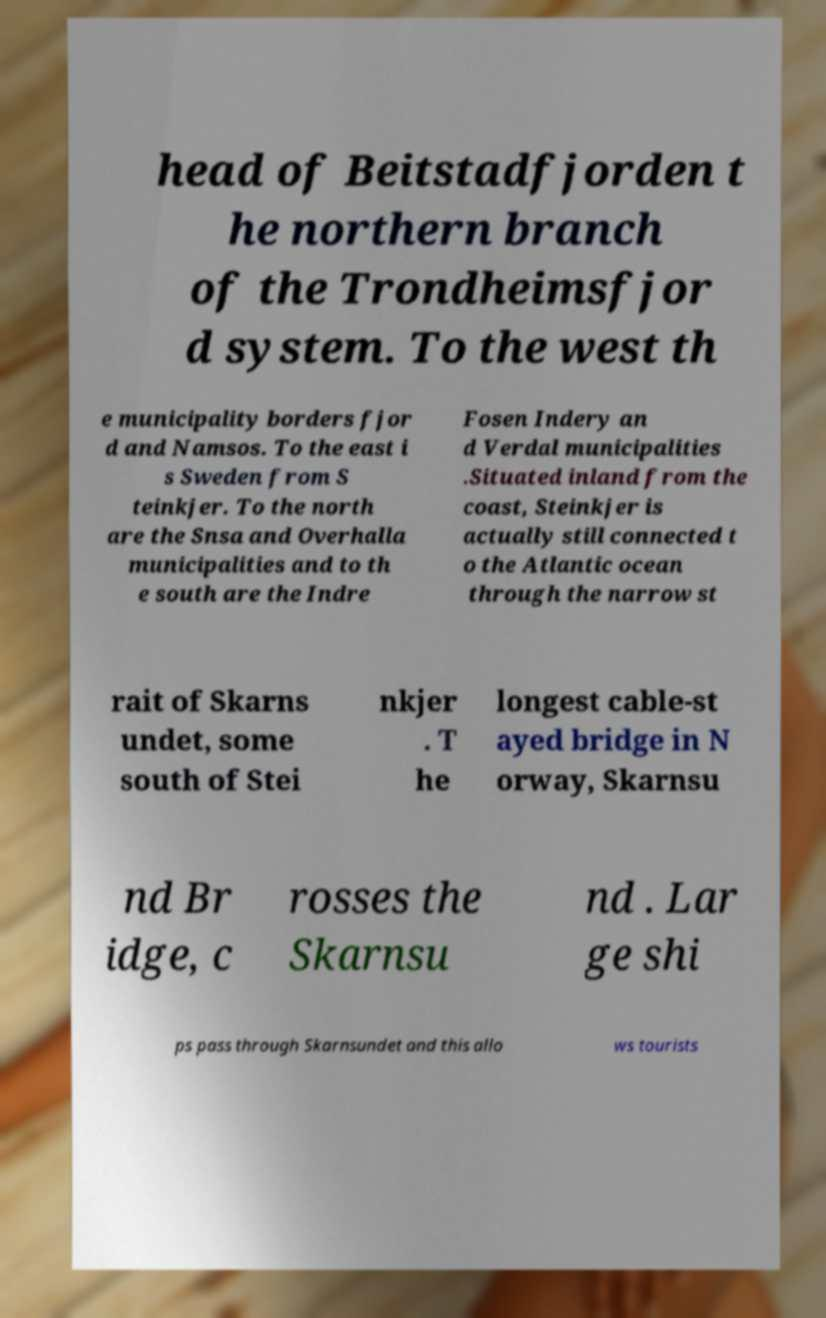Please identify and transcribe the text found in this image. head of Beitstadfjorden t he northern branch of the Trondheimsfjor d system. To the west th e municipality borders fjor d and Namsos. To the east i s Sweden from S teinkjer. To the north are the Snsa and Overhalla municipalities and to th e south are the Indre Fosen Indery an d Verdal municipalities .Situated inland from the coast, Steinkjer is actually still connected t o the Atlantic ocean through the narrow st rait of Skarns undet, some south of Stei nkjer . T he longest cable-st ayed bridge in N orway, Skarnsu nd Br idge, c rosses the Skarnsu nd . Lar ge shi ps pass through Skarnsundet and this allo ws tourists 